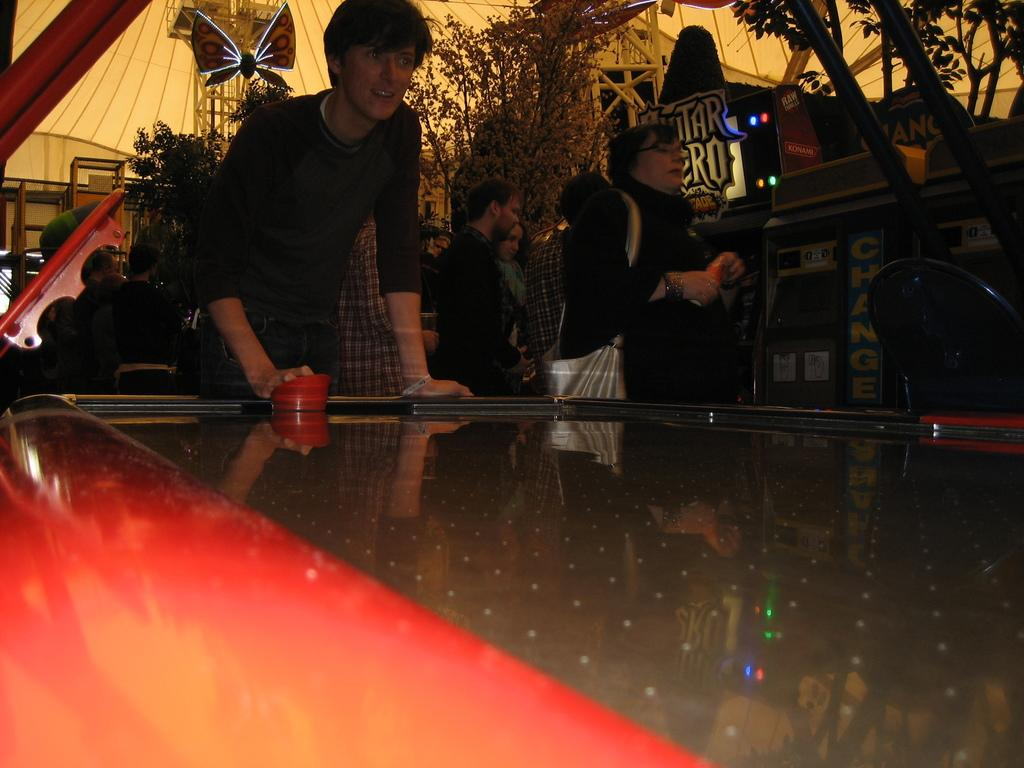How many people are in the image? There are people in the image, but the exact number is not specified. What is the man holding in the image? The man is holding an object in the image. What is in front of the man? There is a table in front of the man. What is the man wearing on his body? The man is wearing a bag. What can be seen in the background of the image? There are boards and trees in the background of the image. What type of riddle is the man trying to solve in the image? There is no indication in the image that the man is trying to solve a riddle. 